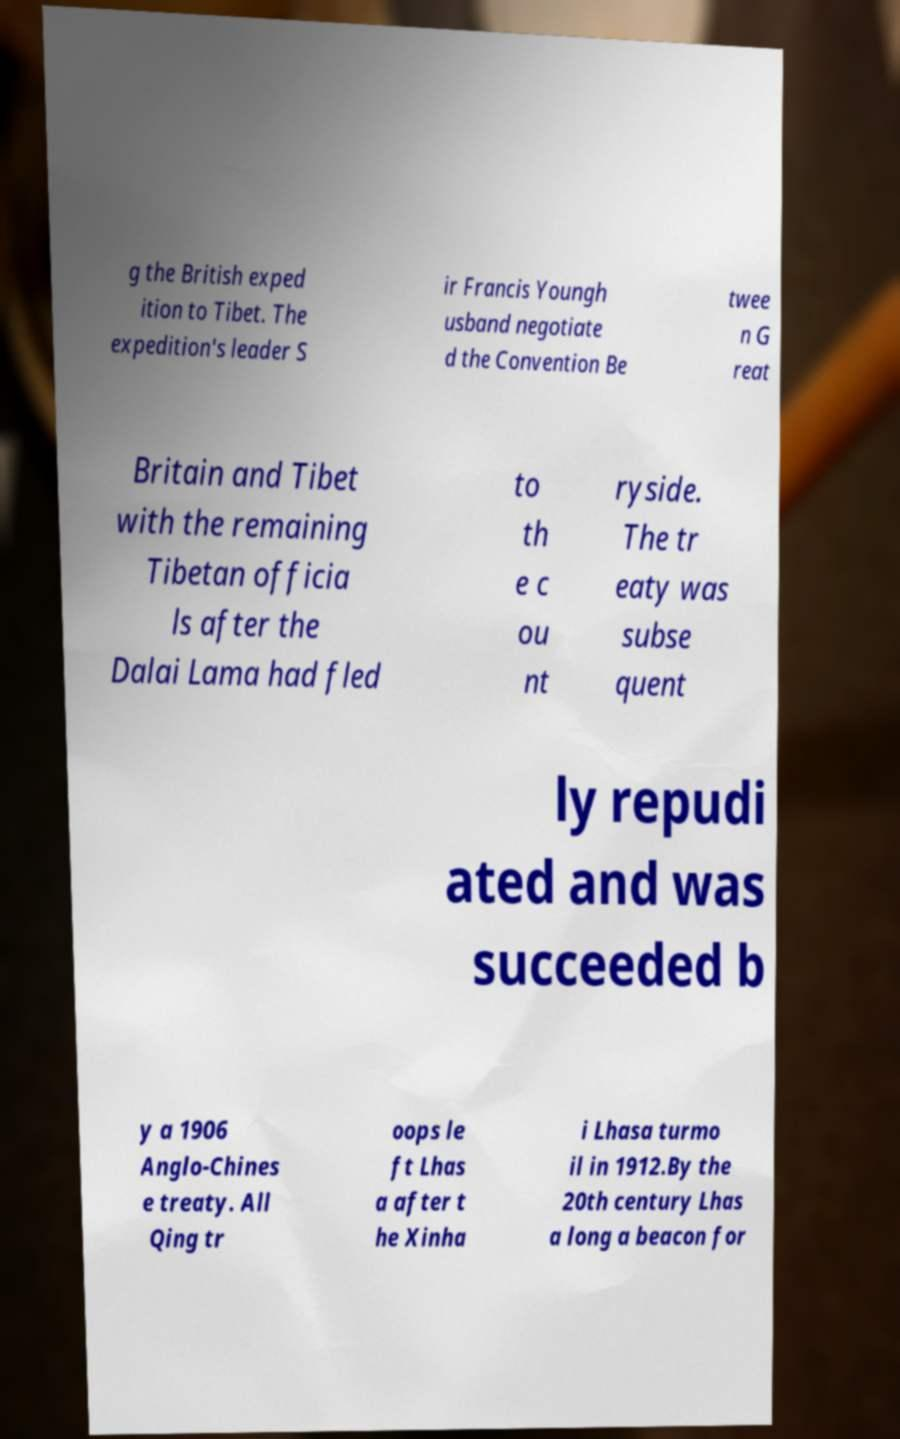For documentation purposes, I need the text within this image transcribed. Could you provide that? g the British exped ition to Tibet. The expedition's leader S ir Francis Youngh usband negotiate d the Convention Be twee n G reat Britain and Tibet with the remaining Tibetan officia ls after the Dalai Lama had fled to th e c ou nt ryside. The tr eaty was subse quent ly repudi ated and was succeeded b y a 1906 Anglo-Chines e treaty. All Qing tr oops le ft Lhas a after t he Xinha i Lhasa turmo il in 1912.By the 20th century Lhas a long a beacon for 